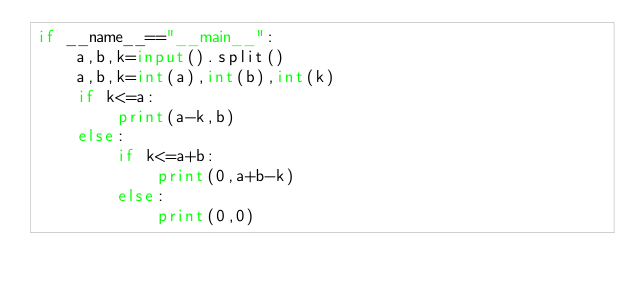Convert code to text. <code><loc_0><loc_0><loc_500><loc_500><_Python_>if __name__=="__main__":
    a,b,k=input().split()
    a,b,k=int(a),int(b),int(k)
    if k<=a:
        print(a-k,b)
    else:
        if k<=a+b:
            print(0,a+b-k)
        else:
            print(0,0)</code> 